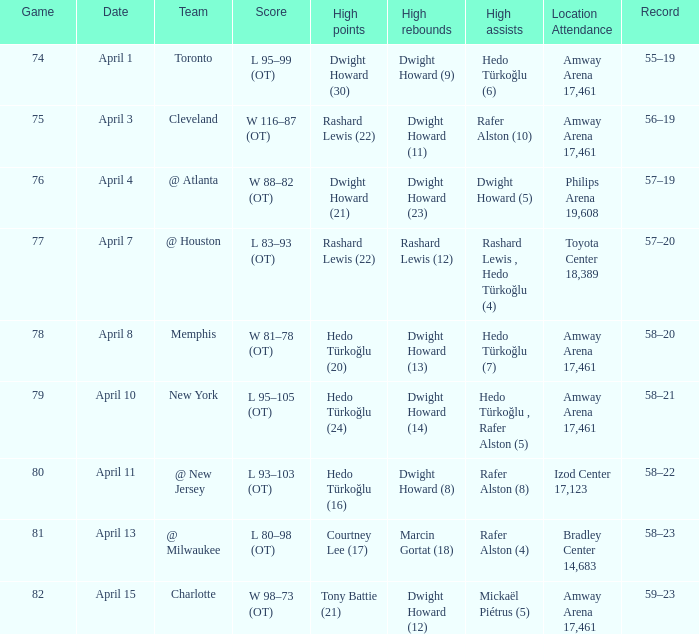What is the highest rebounds for game 81? Marcin Gortat (18). 